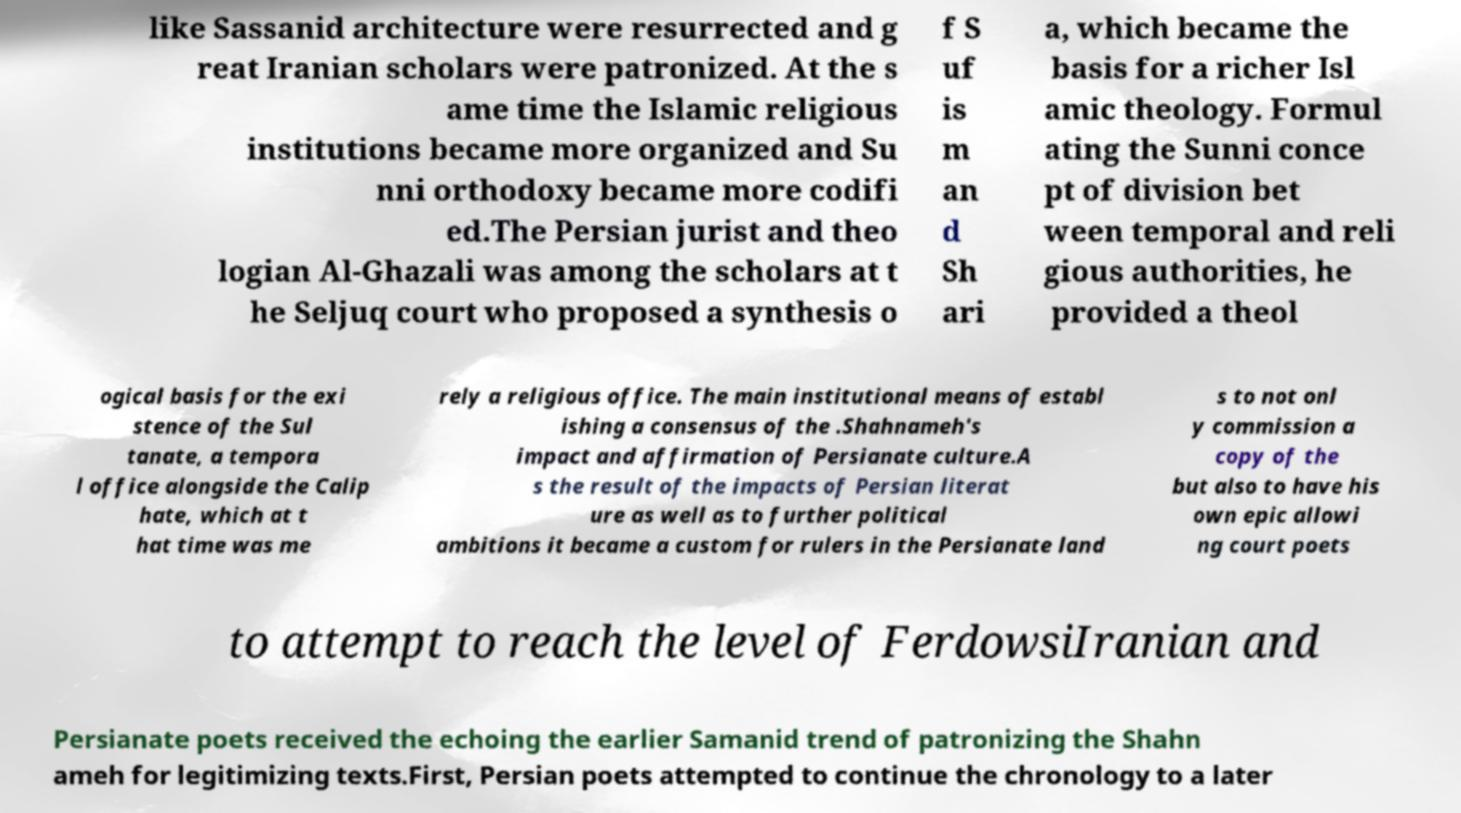Can you accurately transcribe the text from the provided image for me? like Sassanid architecture were resurrected and g reat Iranian scholars were patronized. At the s ame time the Islamic religious institutions became more organized and Su nni orthodoxy became more codifi ed.The Persian jurist and theo logian Al-Ghazali was among the scholars at t he Seljuq court who proposed a synthesis o f S uf is m an d Sh ari a, which became the basis for a richer Isl amic theology. Formul ating the Sunni conce pt of division bet ween temporal and reli gious authorities, he provided a theol ogical basis for the exi stence of the Sul tanate, a tempora l office alongside the Calip hate, which at t hat time was me rely a religious office. The main institutional means of establ ishing a consensus of the .Shahnameh's impact and affirmation of Persianate culture.A s the result of the impacts of Persian literat ure as well as to further political ambitions it became a custom for rulers in the Persianate land s to not onl y commission a copy of the but also to have his own epic allowi ng court poets to attempt to reach the level of FerdowsiIranian and Persianate poets received the echoing the earlier Samanid trend of patronizing the Shahn ameh for legitimizing texts.First, Persian poets attempted to continue the chronology to a later 